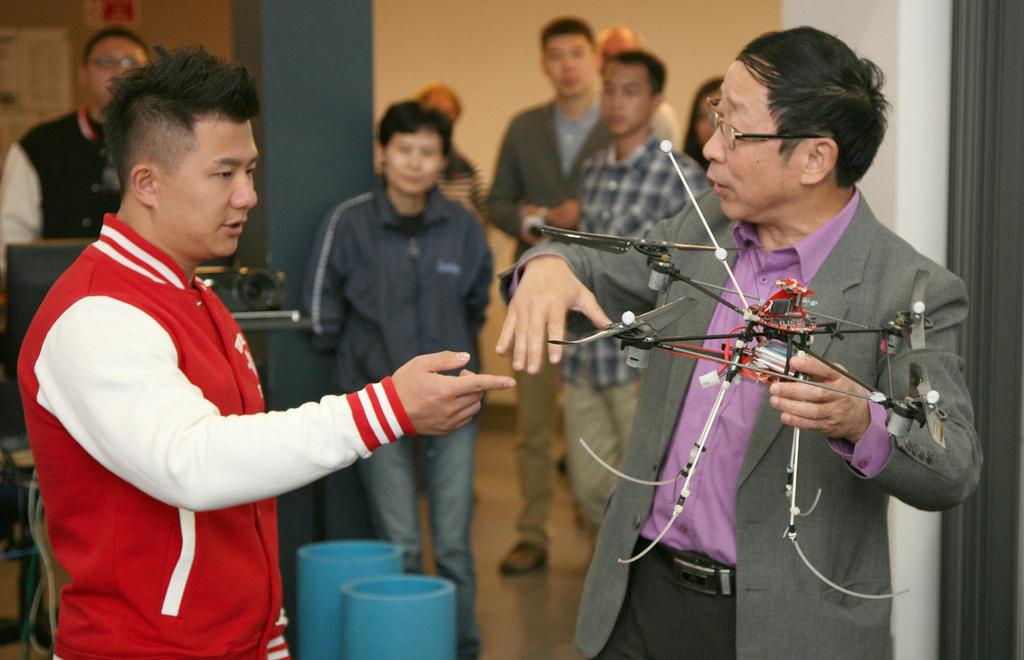How many people are present in the image? A: There are people in the image, but the exact number is not specified. What is one of the architectural features in the image? There is a pillar in the image. What is another feature of the environment in the image? There is a wall in the image. What type of decorations can be seen in the image? There are posters in the image. What else can be found in the image besides people and architectural features? There are objects in the image. What is one person doing with an object in the image? One person is holding an object in the image. What type of curve can be seen in the snow in the image? There is no snow present in the image, so there cannot be any curves in the snow. 